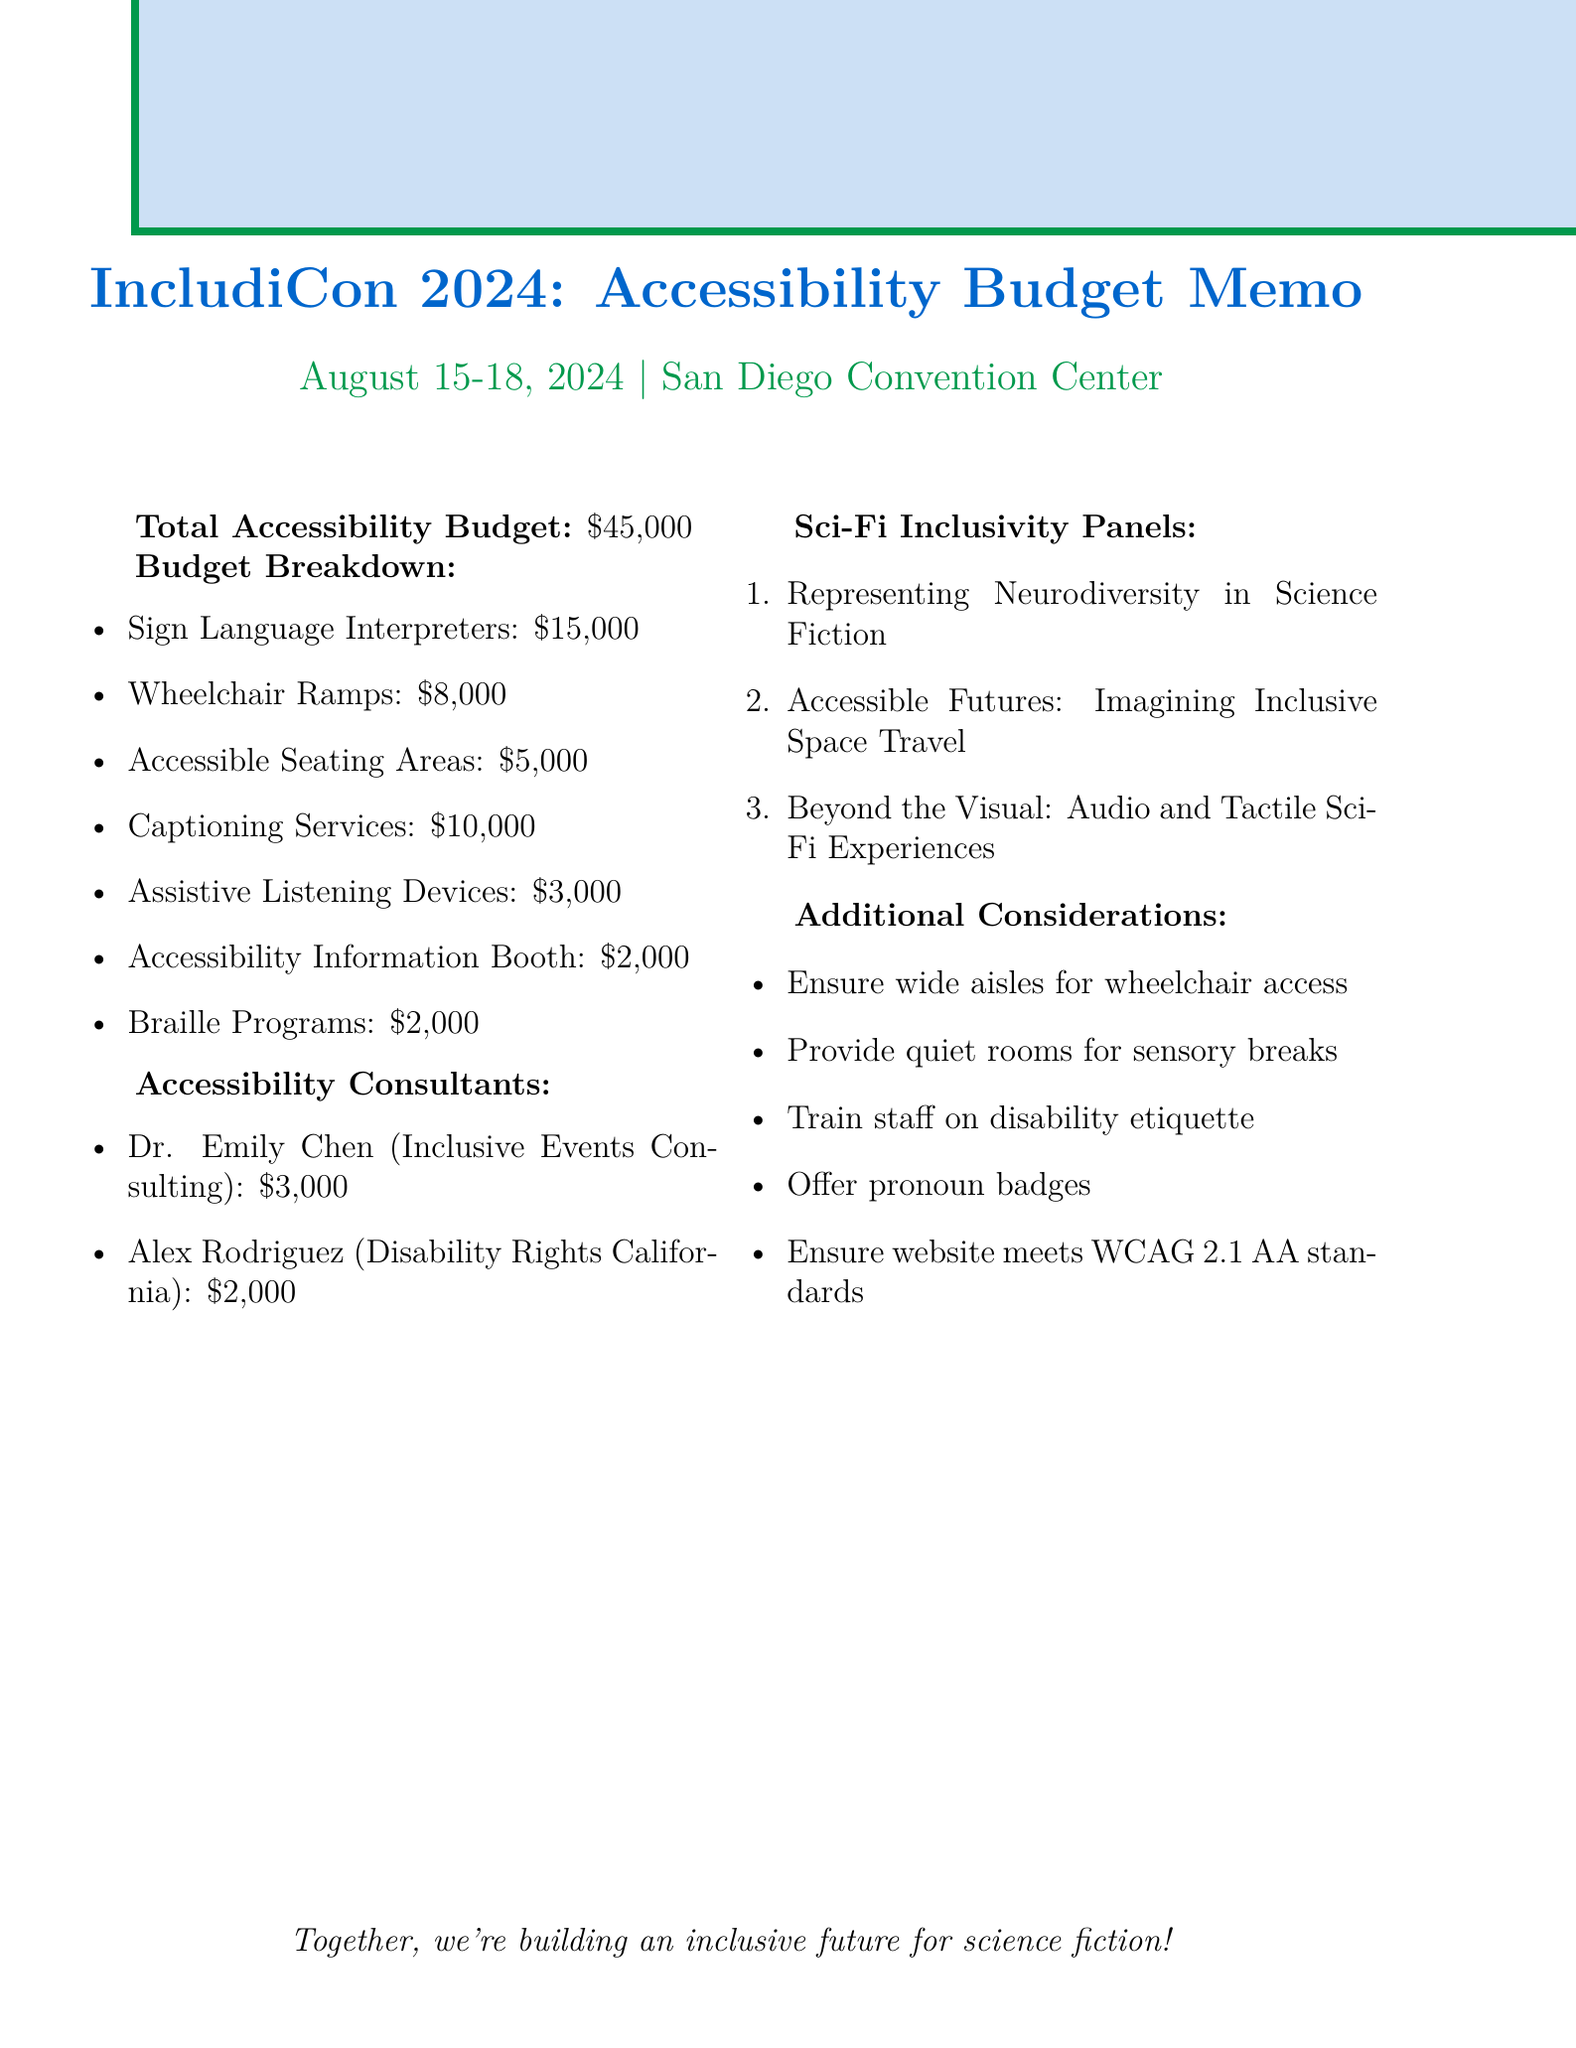What is the total accessibility budget? The total accessibility budget is stated as a single figure in the document.
Answer: $45,000 How much is allocated for sign language interpreters? The cost for sign language interpreters is specifically mentioned in the budget breakdown section.
Answer: $15,000 Who is providing the captioning services? The organization responsible for providing captioning services is detailed in the budget breakdown.
Answer: Caption First How many wheelchair ramps will be rented? The document specifies the number of ramps included in the budget breakdown.
Answer: 10 What is the fee for Dr. Emily Chen? The fee for one of the accessibility consultants is explicitly stated in the document.
Answer: $3,000 What type of panels are included in the sci-fi inclusivity section? The document lists specific titles of panels focusing on inclusivity in science fiction.
Answer: Representing Neurodiversity in Science Fiction, Accessible Futures: Imagining Inclusive Space Travel, Beyond the Visual: Audio and Tactile Sci-Fi Experiences What is one of the additional considerations noted for accessibility? Several considerations are listed in the document that aim to enhance accessibility at the convention.
Answer: Ensure wide aisles for wheelchair access How many assistive listening devices are rented? The number of assistive listening devices is explicitly mentioned in the budget breakdown.
Answer: 50 